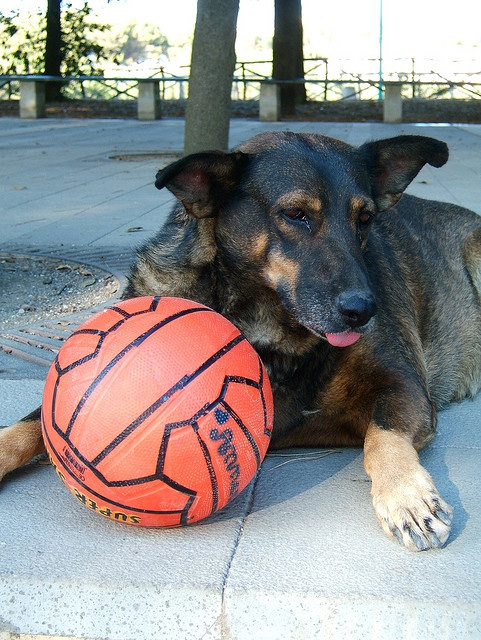Describe the objects in this image and their specific colors. I can see dog in white, black, gray, blue, and darkblue tones, sports ball in white, salmon, and gray tones, bench in white, black, gray, and darkgray tones, and bench in white, gray, and darkgray tones in this image. 